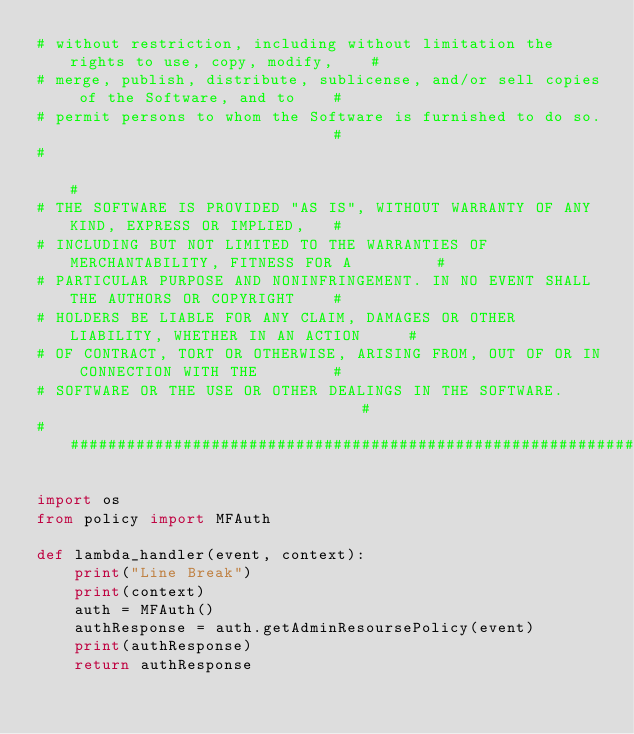Convert code to text. <code><loc_0><loc_0><loc_500><loc_500><_Python_># without restriction, including without limitation the rights to use, copy, modify,    #
# merge, publish, distribute, sublicense, and/or sell copies of the Software, and to    #
# permit persons to whom the Software is furnished to do so.                            #
#                                                                                       #
# THE SOFTWARE IS PROVIDED "AS IS", WITHOUT WARRANTY OF ANY KIND, EXPRESS OR IMPLIED,   #
# INCLUDING BUT NOT LIMITED TO THE WARRANTIES OF MERCHANTABILITY, FITNESS FOR A         #
# PARTICULAR PURPOSE AND NONINFRINGEMENT. IN NO EVENT SHALL THE AUTHORS OR COPYRIGHT    #
# HOLDERS BE LIABLE FOR ANY CLAIM, DAMAGES OR OTHER LIABILITY, WHETHER IN AN ACTION     #
# OF CONTRACT, TORT OR OTHERWISE, ARISING FROM, OUT OF OR IN CONNECTION WITH THE        #
# SOFTWARE OR THE USE OR OTHER DEALINGS IN THE SOFTWARE.                                #
#########################################################################################

import os
from policy import MFAuth

def lambda_handler(event, context):
    print("Line Break")
    print(context)
    auth = MFAuth()
    authResponse = auth.getAdminResoursePolicy(event)
    print(authResponse)
    return authResponse
</code> 